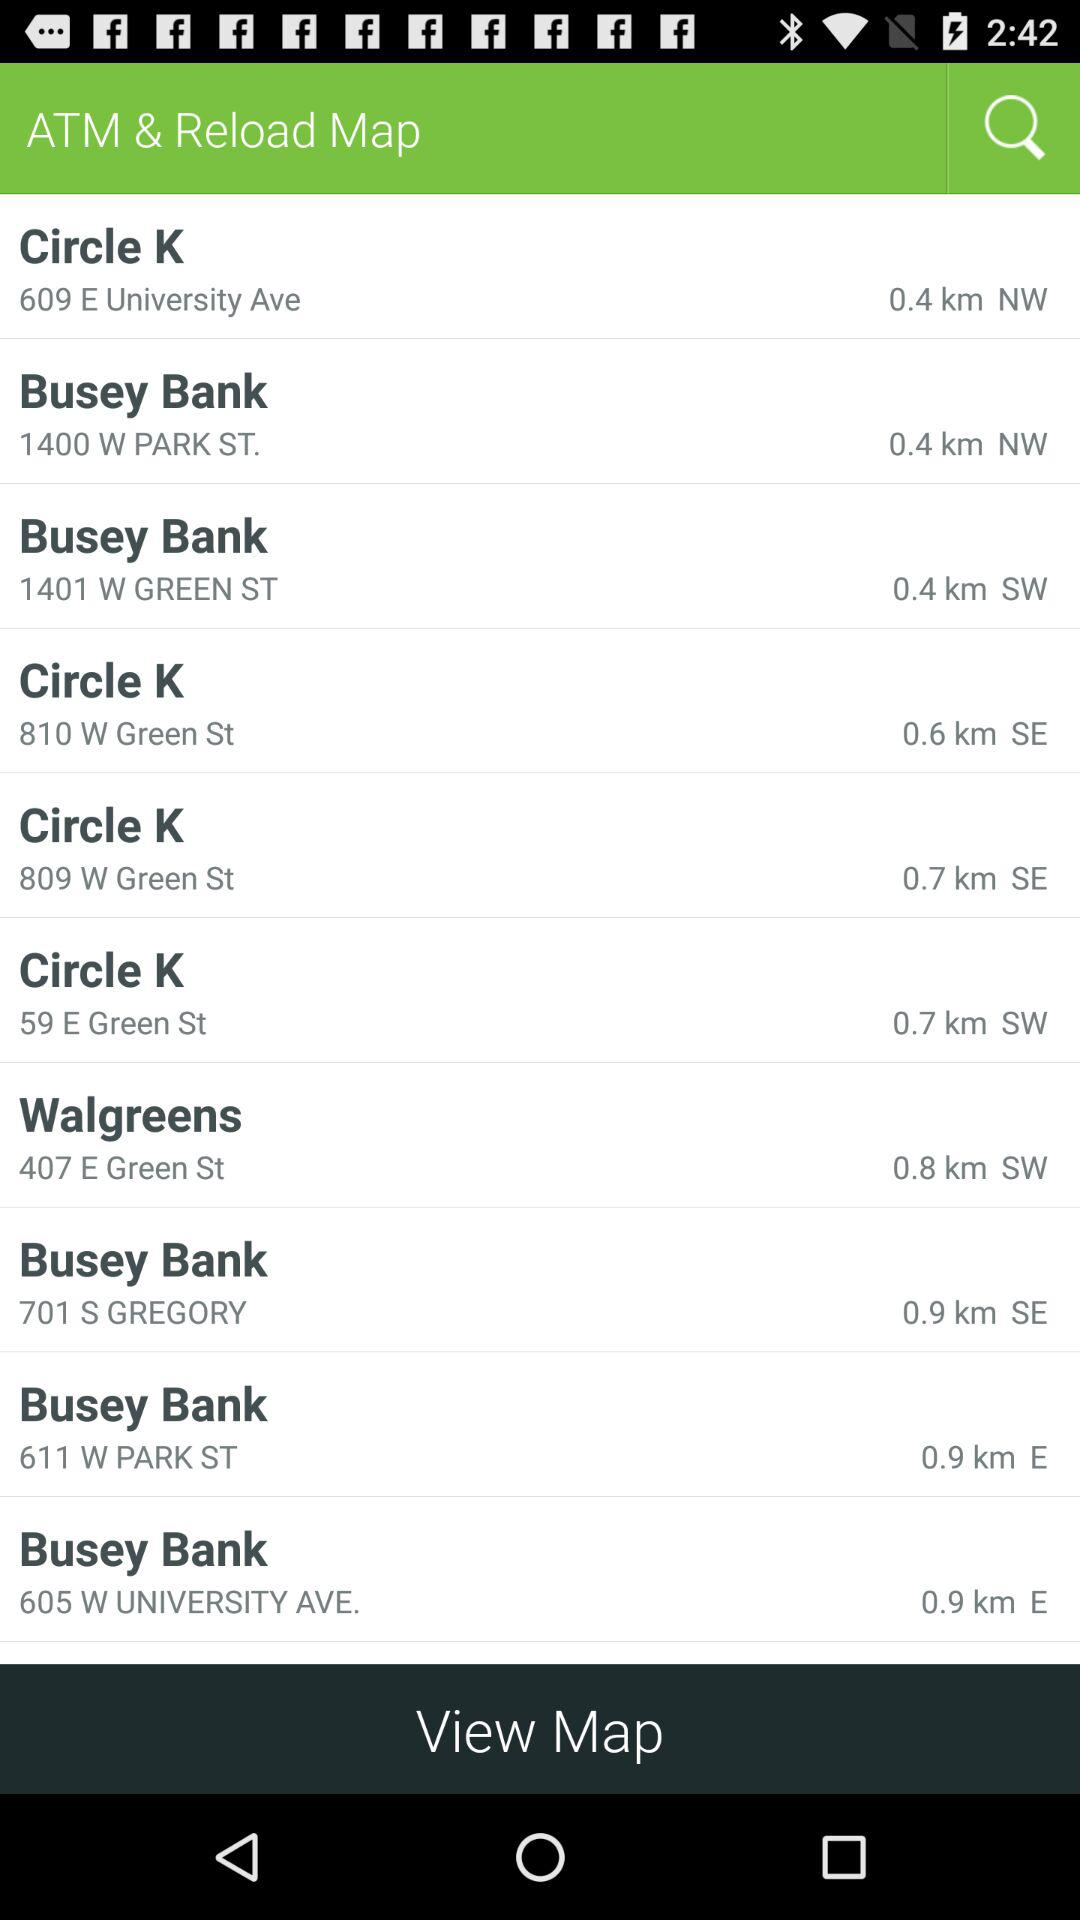Which location is farther from the center of the map, Busey Bank at 611 W PARK ST or Busey Bank at 701 S GREGORY?
Answer the question using a single word or phrase. Busey Bank at 701 S GREGORY 